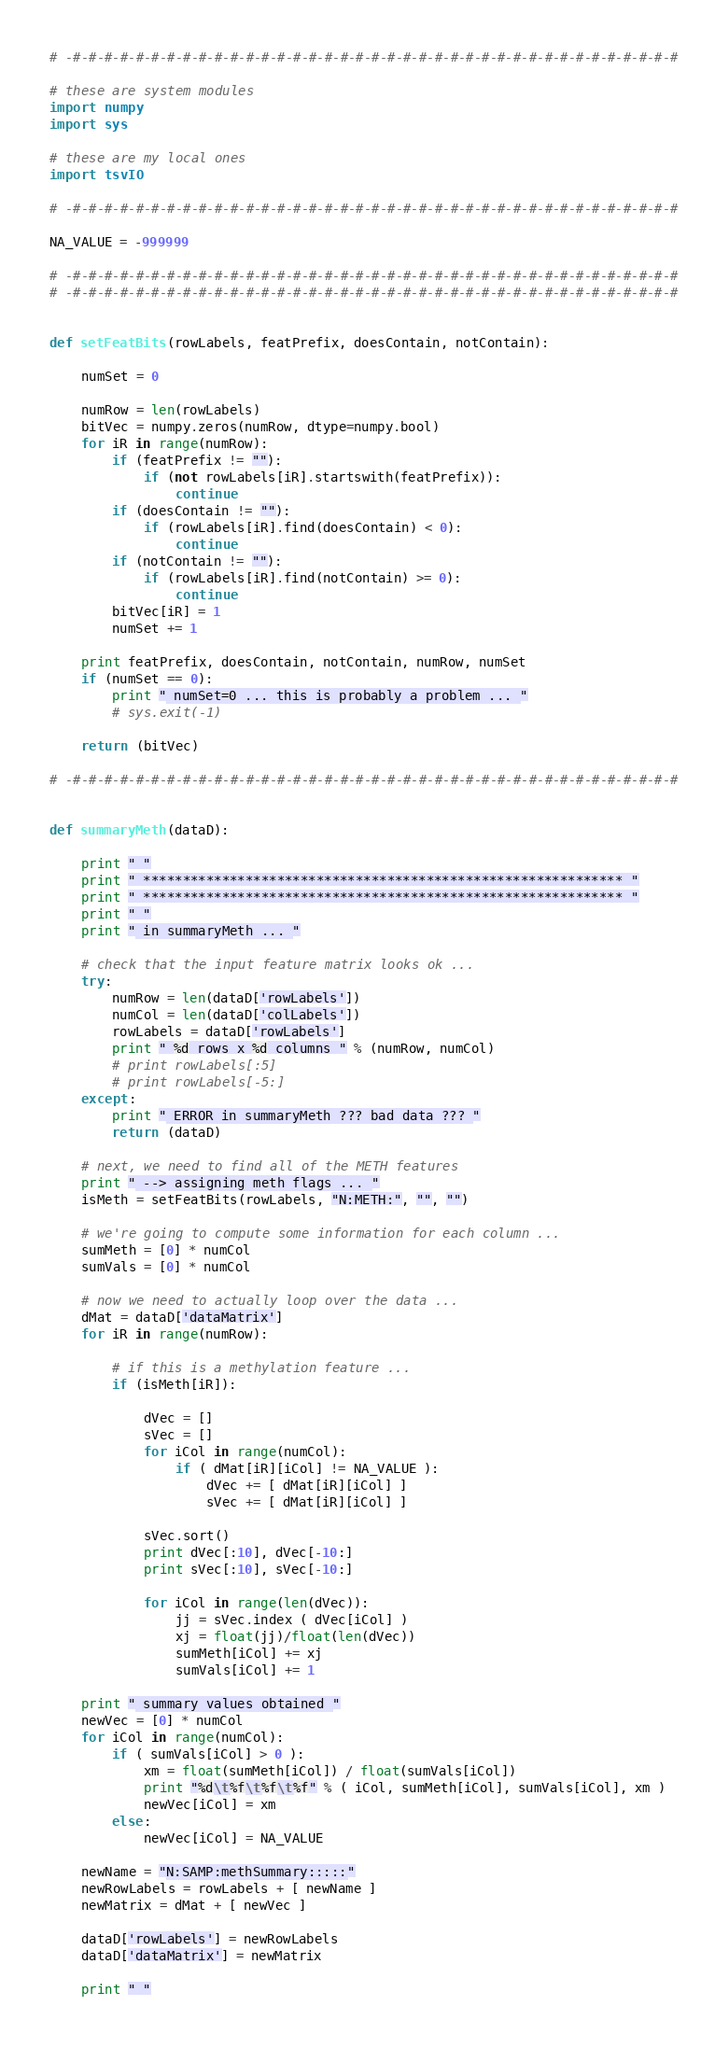Convert code to text. <code><loc_0><loc_0><loc_500><loc_500><_Python_># -#-#-#-#-#-#-#-#-#-#-#-#-#-#-#-#-#-#-#-#-#-#-#-#-#-#-#-#-#-#-#-#-#-#-#-#-#-#-#

# these are system modules
import numpy
import sys

# these are my local ones
import tsvIO

# -#-#-#-#-#-#-#-#-#-#-#-#-#-#-#-#-#-#-#-#-#-#-#-#-#-#-#-#-#-#-#-#-#-#-#-#-#-#-#

NA_VALUE = -999999

# -#-#-#-#-#-#-#-#-#-#-#-#-#-#-#-#-#-#-#-#-#-#-#-#-#-#-#-#-#-#-#-#-#-#-#-#-#-#-#
# -#-#-#-#-#-#-#-#-#-#-#-#-#-#-#-#-#-#-#-#-#-#-#-#-#-#-#-#-#-#-#-#-#-#-#-#-#-#-#


def setFeatBits(rowLabels, featPrefix, doesContain, notContain):

    numSet = 0

    numRow = len(rowLabels)
    bitVec = numpy.zeros(numRow, dtype=numpy.bool)
    for iR in range(numRow):
        if (featPrefix != ""):
            if (not rowLabels[iR].startswith(featPrefix)):
                continue
        if (doesContain != ""):
            if (rowLabels[iR].find(doesContain) < 0):
                continue
        if (notContain != ""):
            if (rowLabels[iR].find(notContain) >= 0):
                continue
        bitVec[iR] = 1
        numSet += 1

    print featPrefix, doesContain, notContain, numRow, numSet
    if (numSet == 0):
        print " numSet=0 ... this is probably a problem ... "
        # sys.exit(-1)

    return (bitVec)

# -#-#-#-#-#-#-#-#-#-#-#-#-#-#-#-#-#-#-#-#-#-#-#-#-#-#-#-#-#-#-#-#-#-#-#-#-#-#-#


def summaryMeth(dataD):

    print " "
    print " ************************************************************* "
    print " ************************************************************* "
    print " "
    print " in summaryMeth ... "

    # check that the input feature matrix looks ok ...
    try:
        numRow = len(dataD['rowLabels'])
        numCol = len(dataD['colLabels'])
        rowLabels = dataD['rowLabels']
        print " %d rows x %d columns " % (numRow, numCol)
        # print rowLabels[:5]
        # print rowLabels[-5:]
    except:
        print " ERROR in summaryMeth ??? bad data ??? "
        return (dataD)

    # next, we need to find all of the METH features
    print " --> assigning meth flags ... "
    isMeth = setFeatBits(rowLabels, "N:METH:", "", "")

    # we're going to compute some information for each column ...
    sumMeth = [0] * numCol
    sumVals = [0] * numCol

    # now we need to actually loop over the data ...
    dMat = dataD['dataMatrix']
    for iR in range(numRow):

        # if this is a methylation feature ...
        if (isMeth[iR]):

            dVec = []
            sVec = []
            for iCol in range(numCol):
                if ( dMat[iR][iCol] != NA_VALUE ):
                    dVec += [ dMat[iR][iCol] ]
                    sVec += [ dMat[iR][iCol] ]

            sVec.sort()
            print dVec[:10], dVec[-10:]
            print sVec[:10], sVec[-10:]

            for iCol in range(len(dVec)):
                jj = sVec.index ( dVec[iCol] )
                xj = float(jj)/float(len(dVec))
                sumMeth[iCol] += xj
                sumVals[iCol] += 1

    print " summary values obtained "
    newVec = [0] * numCol
    for iCol in range(numCol):
        if ( sumVals[iCol] > 0 ):
            xm = float(sumMeth[iCol]) / float(sumVals[iCol])
            print "%d\t%f\t%f\t%f" % ( iCol, sumMeth[iCol], sumVals[iCol], xm )
            newVec[iCol] = xm
        else:
            newVec[iCol] = NA_VALUE

    newName = "N:SAMP:methSummary:::::"
    newRowLabels = rowLabels + [ newName ]
    newMatrix = dMat + [ newVec ]

    dataD['rowLabels'] = newRowLabels
    dataD['dataMatrix'] = newMatrix

    print " "</code> 